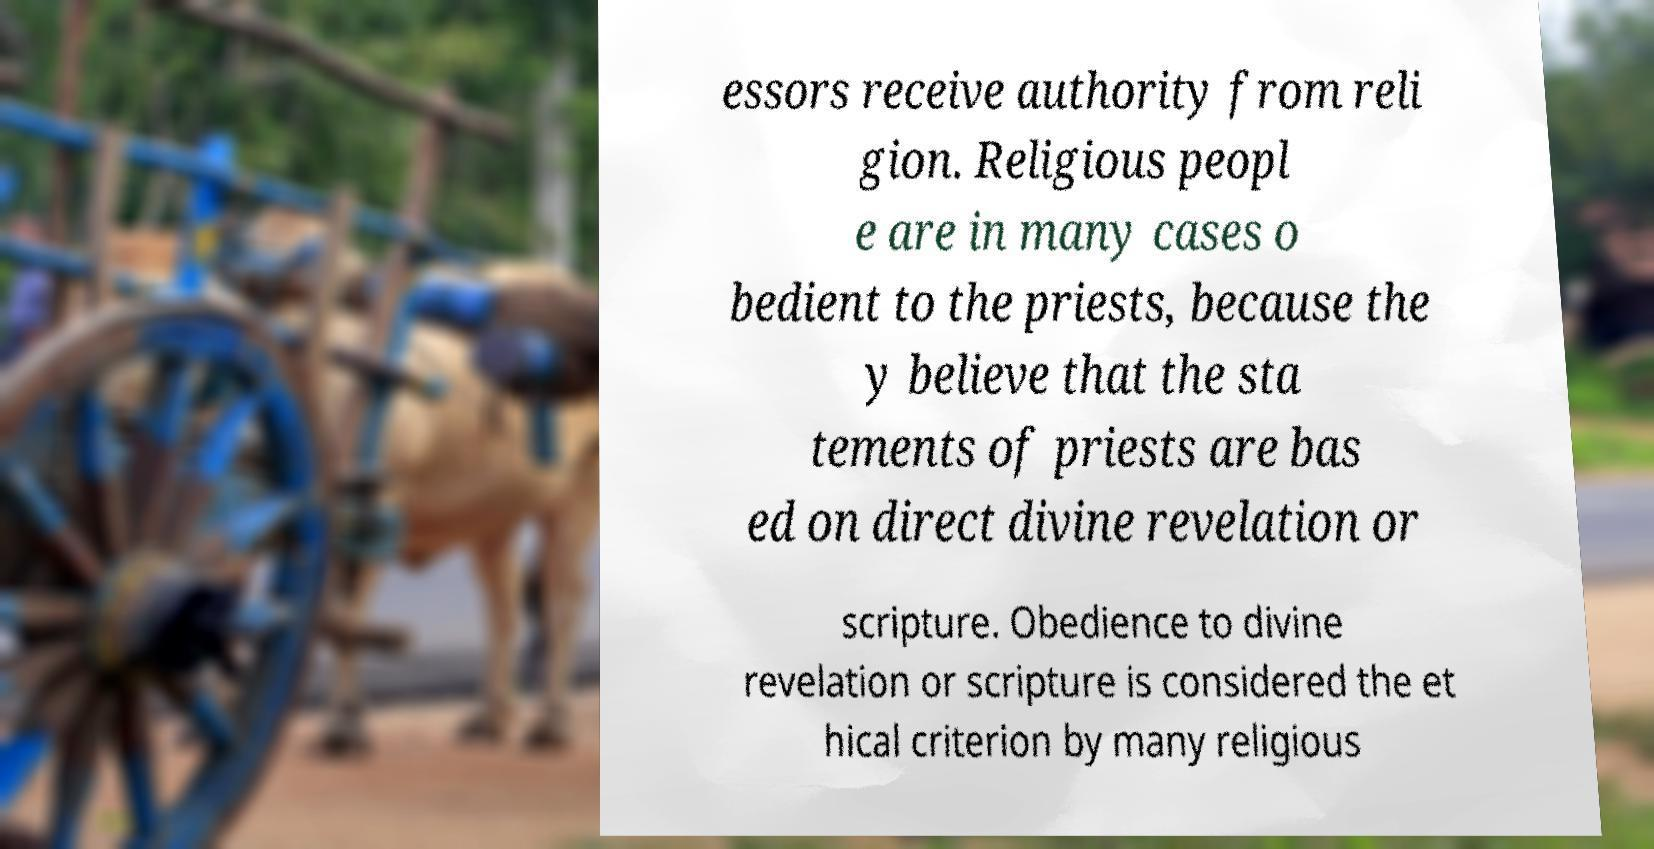Can you read and provide the text displayed in the image?This photo seems to have some interesting text. Can you extract and type it out for me? essors receive authority from reli gion. Religious peopl e are in many cases o bedient to the priests, because the y believe that the sta tements of priests are bas ed on direct divine revelation or scripture. Obedience to divine revelation or scripture is considered the et hical criterion by many religious 